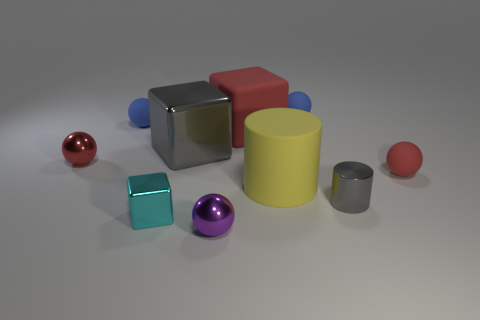Is the number of small metal balls less than the number of small purple balls?
Offer a terse response. No. Is the material of the tiny gray cylinder that is on the right side of the cyan shiny block the same as the large gray thing?
Offer a very short reply. Yes. There is a red rubber sphere; are there any small cyan objects behind it?
Offer a very short reply. No. What is the color of the cylinder that is to the right of the tiny blue rubber ball that is on the right side of the large yellow cylinder that is in front of the red cube?
Offer a terse response. Gray. What is the shape of the cyan object that is the same size as the red matte sphere?
Your answer should be compact. Cube. Is the number of tiny purple metal balls greater than the number of green cubes?
Provide a succinct answer. Yes. Is there a big yellow thing left of the small matte ball that is on the left side of the purple ball?
Your answer should be compact. No. What is the color of the large rubber thing that is the same shape as the cyan metal thing?
Offer a very short reply. Red. Is there anything else that has the same shape as the small gray shiny thing?
Your response must be concise. Yes. What color is the large cube that is the same material as the gray cylinder?
Provide a succinct answer. Gray. 